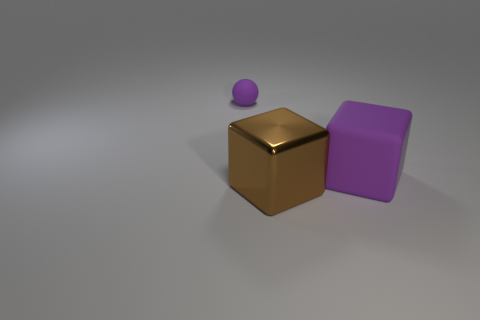How many things are tiny brown cubes or large purple things?
Provide a short and direct response. 1. Is the metal thing the same shape as the small matte object?
Make the answer very short. No. Are there any big purple cubes that have the same material as the tiny purple thing?
Keep it short and to the point. Yes. Is there a big purple rubber thing on the right side of the brown block in front of the tiny rubber thing?
Your response must be concise. Yes. There is a cube on the left side of the purple matte cube; is its size the same as the big purple rubber block?
Provide a short and direct response. Yes. The matte sphere has what size?
Offer a very short reply. Small. Are there any large matte objects of the same color as the tiny rubber sphere?
Ensure brevity in your answer.  Yes. How many tiny objects are cyan rubber balls or metal things?
Provide a short and direct response. 0. What is the size of the thing that is both right of the tiny rubber object and on the left side of the large purple matte thing?
Provide a succinct answer. Large. There is a tiny purple object; what number of large things are in front of it?
Offer a very short reply. 2. 